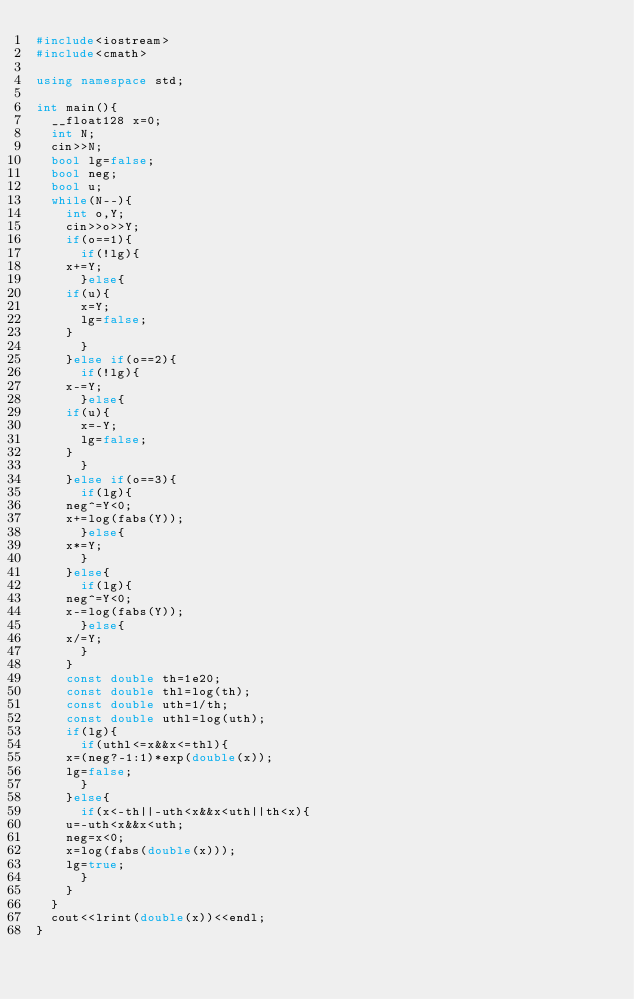Convert code to text. <code><loc_0><loc_0><loc_500><loc_500><_C++_>#include<iostream>
#include<cmath>

using namespace std;

int main(){
  __float128 x=0;
  int N;
  cin>>N;
  bool lg=false;
  bool neg;
  bool u;
  while(N--){
    int o,Y;
    cin>>o>>Y;
    if(o==1){
      if(!lg){
	x+=Y;
      }else{
	if(u){
	  x=Y;
	  lg=false;
	}
      }
    }else if(o==2){
      if(!lg){
	x-=Y;
      }else{
	if(u){
	  x=-Y;
	  lg=false;
	}
      }
    }else if(o==3){
      if(lg){
	neg^=Y<0;
	x+=log(fabs(Y));
      }else{
	x*=Y;
      }
    }else{
      if(lg){
	neg^=Y<0;
	x-=log(fabs(Y));
      }else{
	x/=Y;
      }
    }
    const double th=1e20;
    const double thl=log(th);
    const double uth=1/th;
    const double uthl=log(uth);
    if(lg){
      if(uthl<=x&&x<=thl){
	x=(neg?-1:1)*exp(double(x));
	lg=false;
      }
    }else{
      if(x<-th||-uth<x&&x<uth||th<x){
	u=-uth<x&&x<uth;
	neg=x<0;
	x=log(fabs(double(x)));
	lg=true;
      }
    }
  }
  cout<<lrint(double(x))<<endl;
}</code> 